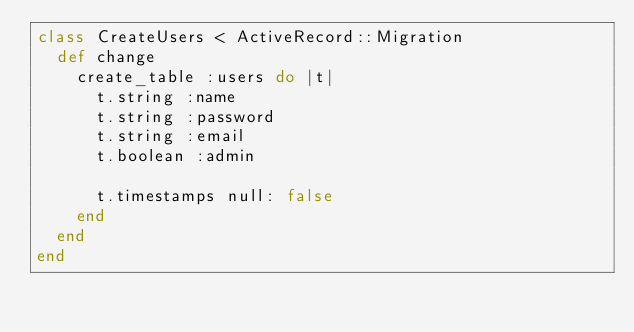<code> <loc_0><loc_0><loc_500><loc_500><_Ruby_>class CreateUsers < ActiveRecord::Migration
  def change
    create_table :users do |t|
      t.string :name
      t.string :password
      t.string :email
      t.boolean :admin

      t.timestamps null: false
    end
  end
end
</code> 